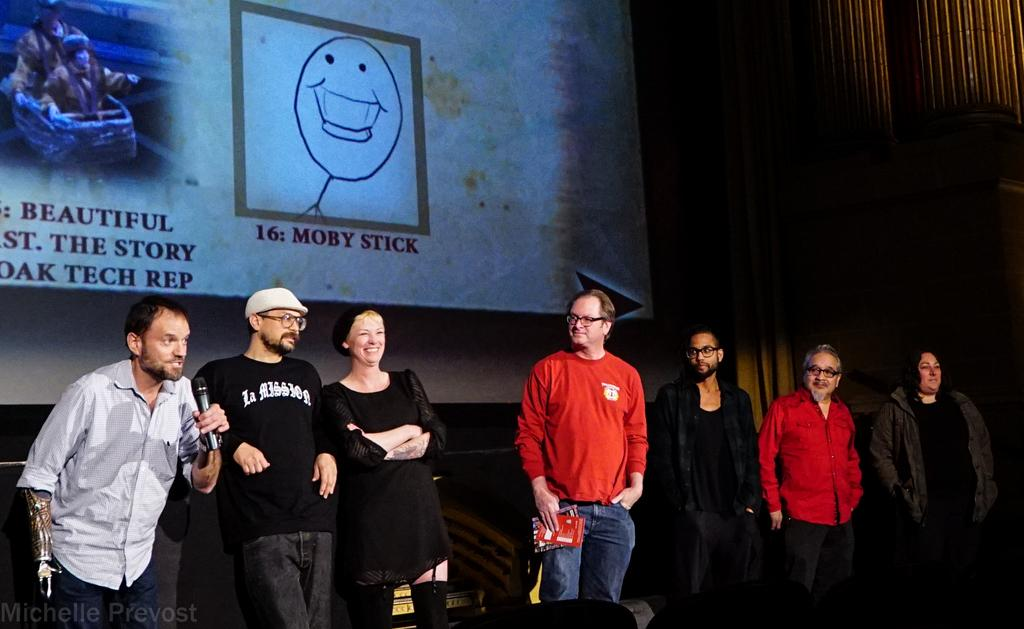What is happening in the image? There are several people on stage in the image. Can you describe any unique features of the people on stage? One person on the left side has a mechanical hand. What can be seen in the background of the image? There is a poster in the background of the image. What type of glove is the person on the right side wearing in the image? There is no person on the right side wearing a glove in the image. Is there a scarf visible on any of the people on stage in the image? There is no scarf visible on any of the people on stage in the image. 